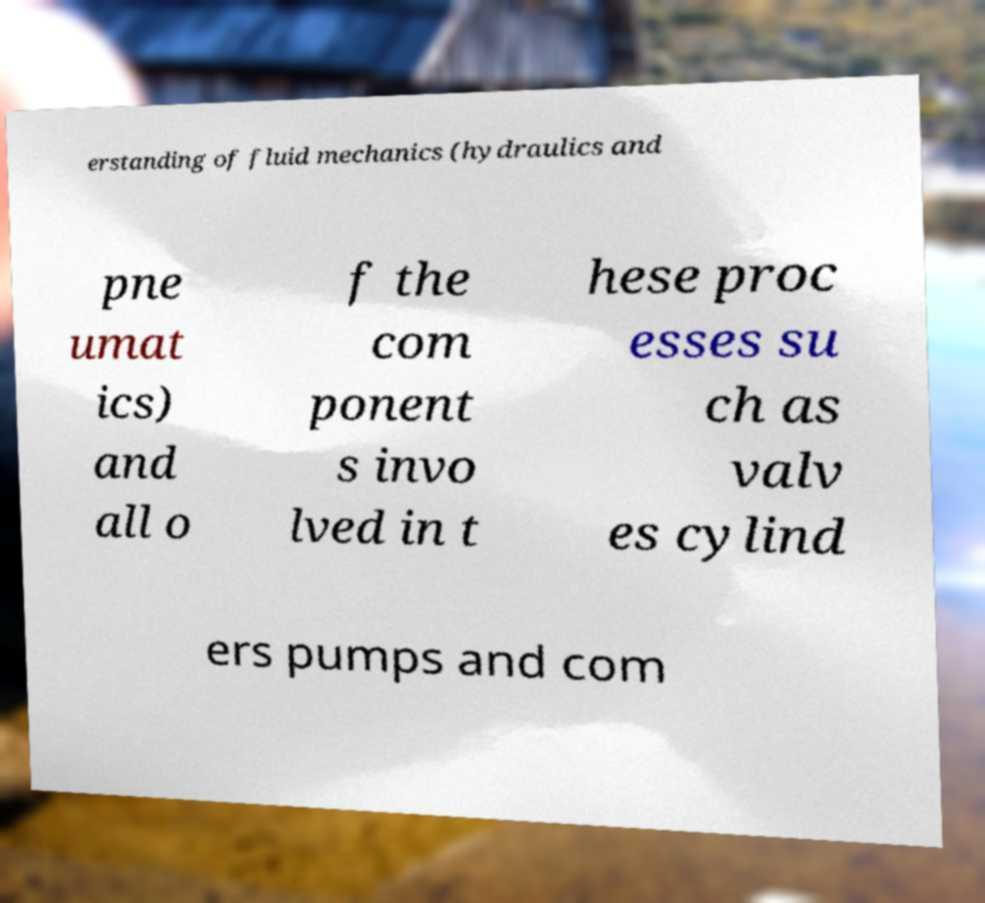Please identify and transcribe the text found in this image. erstanding of fluid mechanics (hydraulics and pne umat ics) and all o f the com ponent s invo lved in t hese proc esses su ch as valv es cylind ers pumps and com 